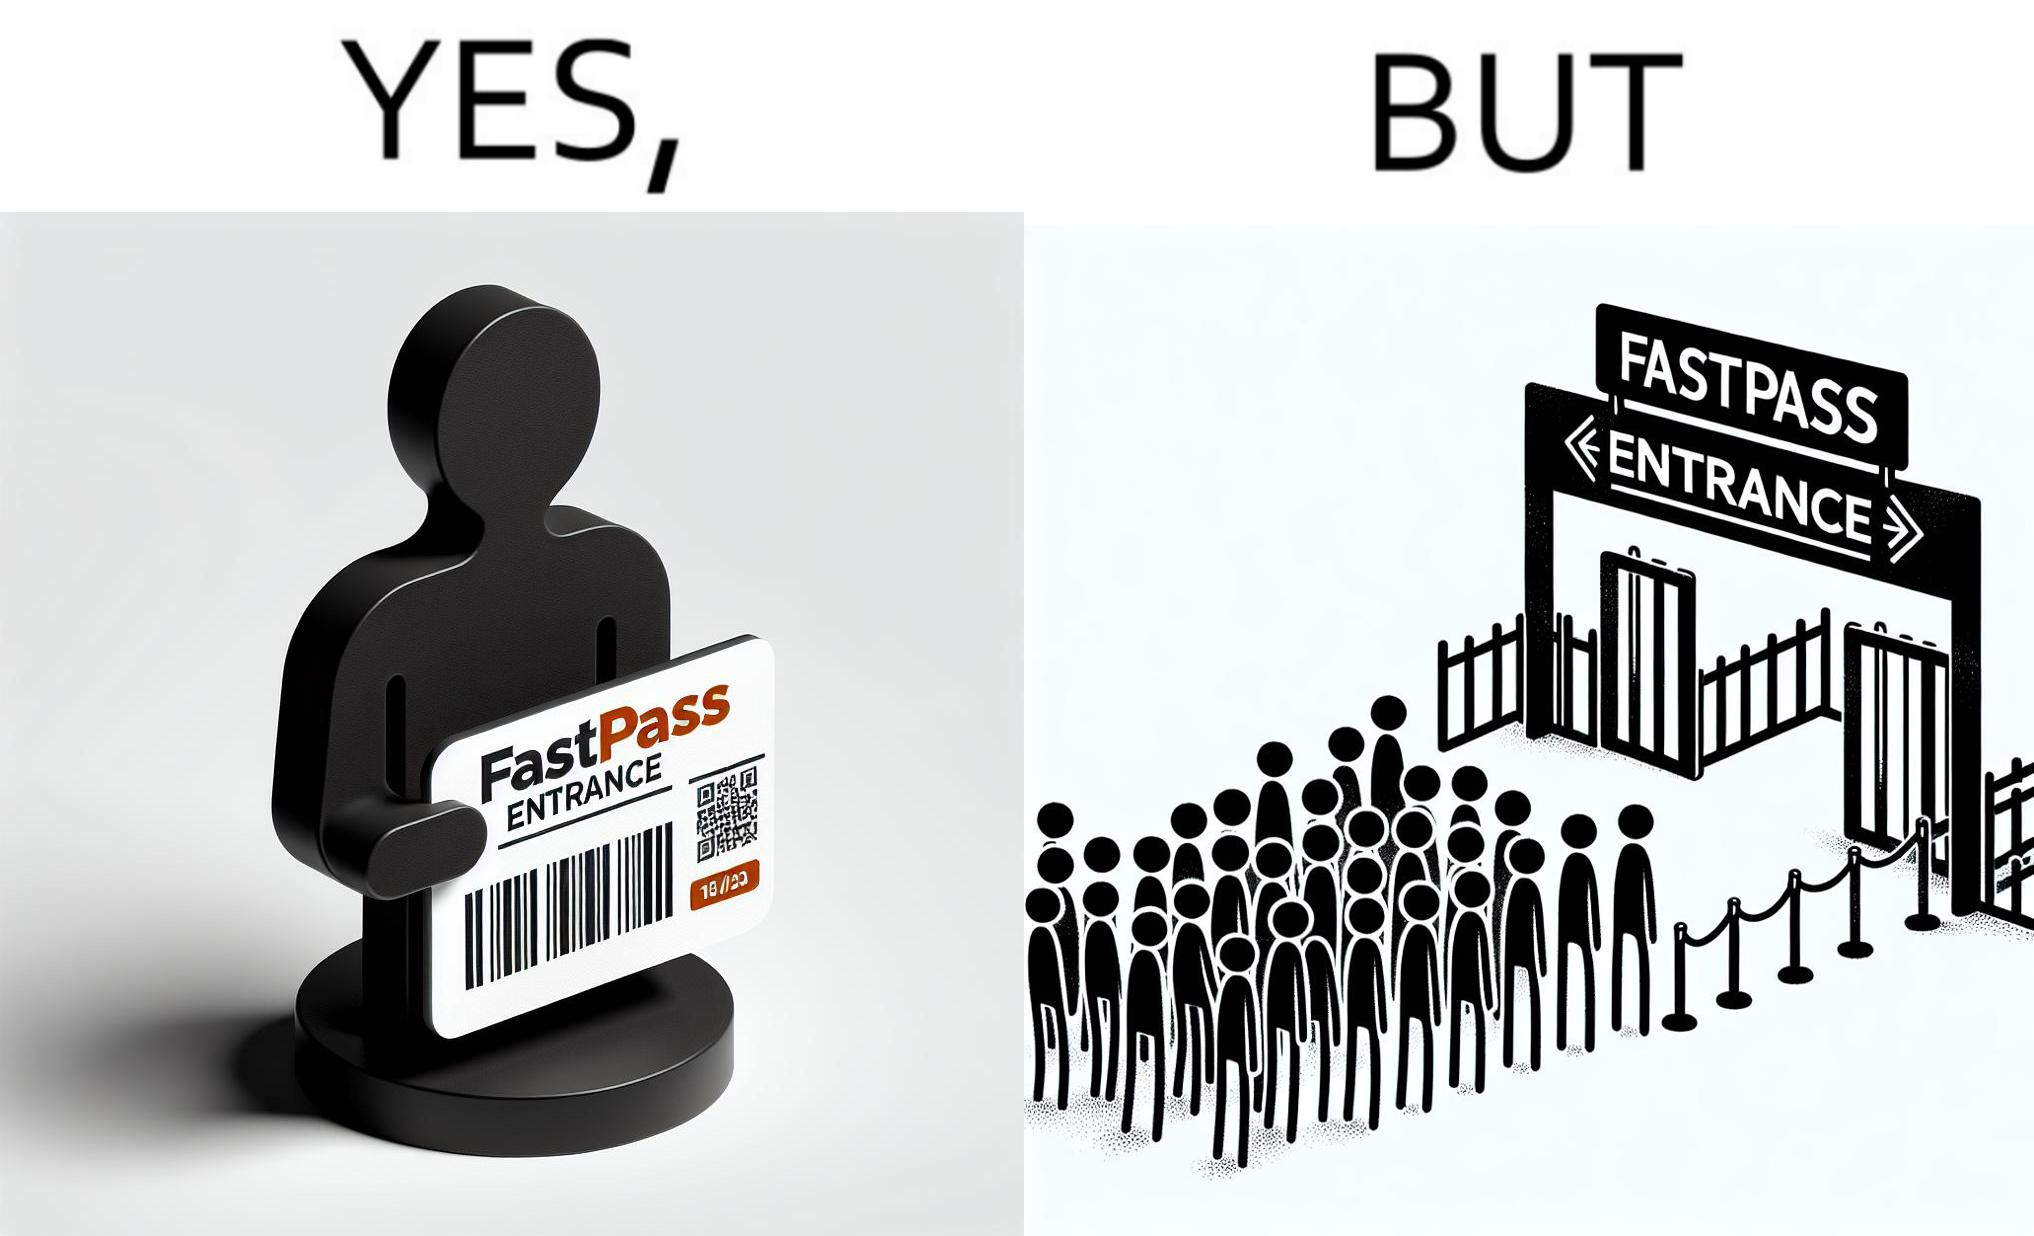Describe the contrast between the left and right parts of this image. In the left part of the image: a person holding a "FASTPASS ENTRANCE" ticket or token of date "15/05/23" with some barcode In the right part of the image: people in a long queue in front of "FASTPASS ENTRANCE"  gate and "ENTRANCE" gate is vacant without any queue 